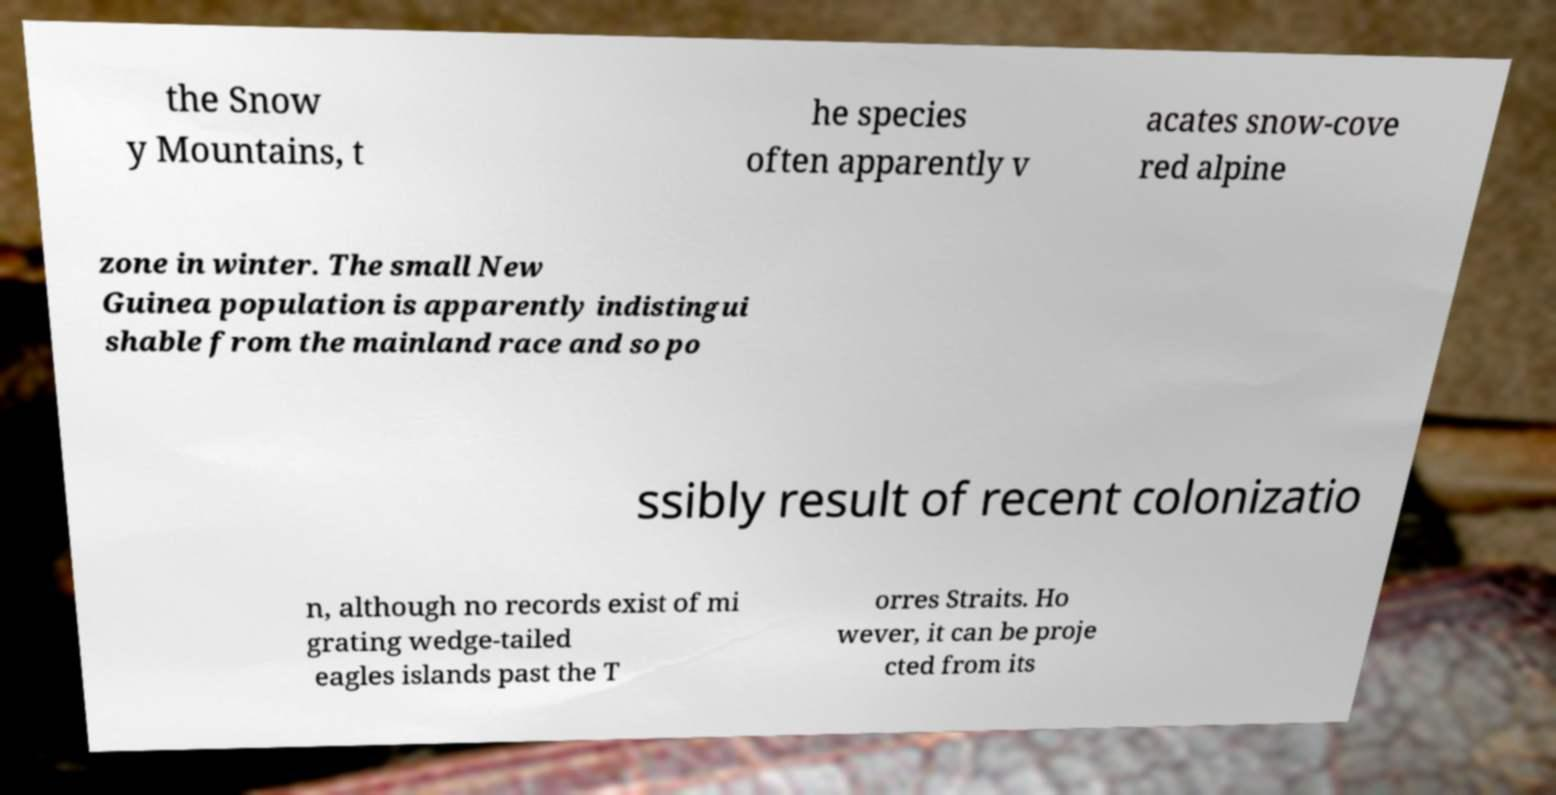Can you accurately transcribe the text from the provided image for me? the Snow y Mountains, t he species often apparently v acates snow-cove red alpine zone in winter. The small New Guinea population is apparently indistingui shable from the mainland race and so po ssibly result of recent colonizatio n, although no records exist of mi grating wedge-tailed eagles islands past the T orres Straits. Ho wever, it can be proje cted from its 